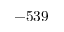Convert formula to latex. <formula><loc_0><loc_0><loc_500><loc_500>- 5 3 9</formula> 